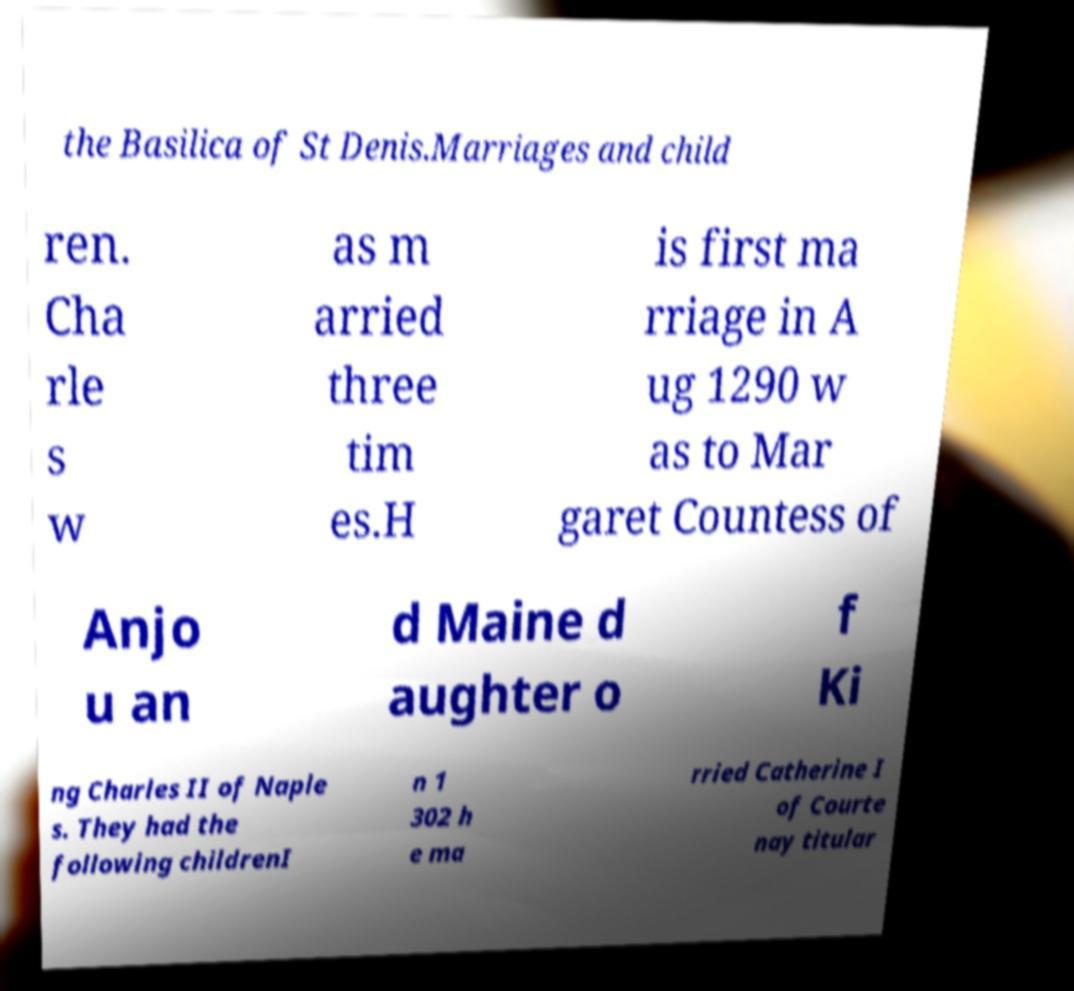Please read and relay the text visible in this image. What does it say? the Basilica of St Denis.Marriages and child ren. Cha rle s w as m arried three tim es.H is first ma rriage in A ug 1290 w as to Mar garet Countess of Anjo u an d Maine d aughter o f Ki ng Charles II of Naple s. They had the following childrenI n 1 302 h e ma rried Catherine I of Courte nay titular 